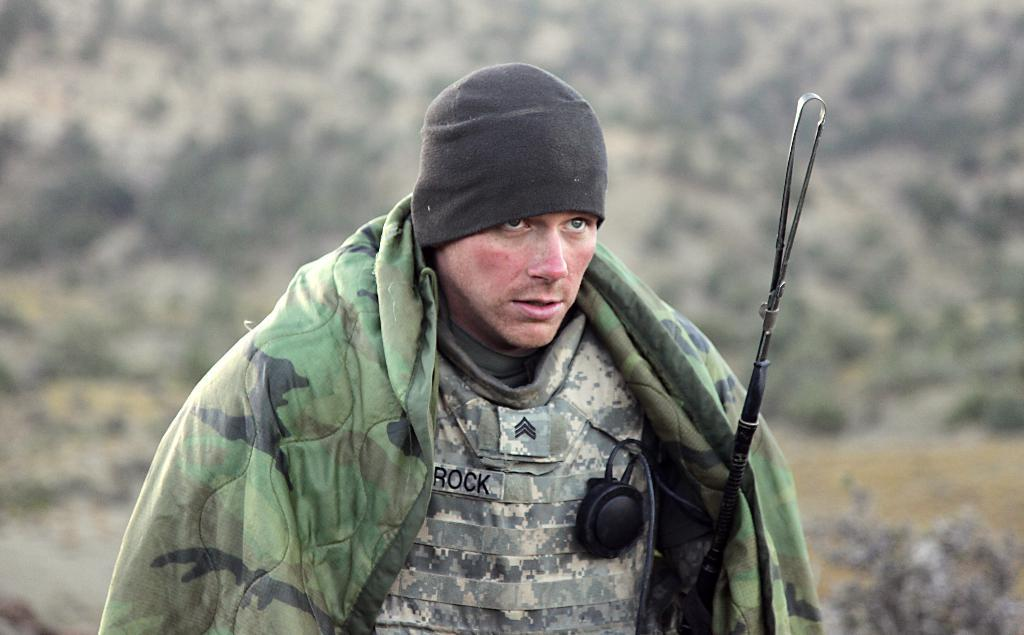Who or what is the main subject in the center of the image? There is a person in the center of the image. What is the person wearing on their head? The person is wearing a cap. What type of clothing is the person wearing on their upper body? The person is wearing a coat. What object is the person holding in their hand? The person is holding a stick. How would you describe the background of the image? The background of the image is blurry. What type of rose can be seen growing on the curtain in the image? There is no rose or curtain present in the image. How many tomatoes are visible on the person's coat in the image? There are no tomatoes visible on the person's coat in the image. 